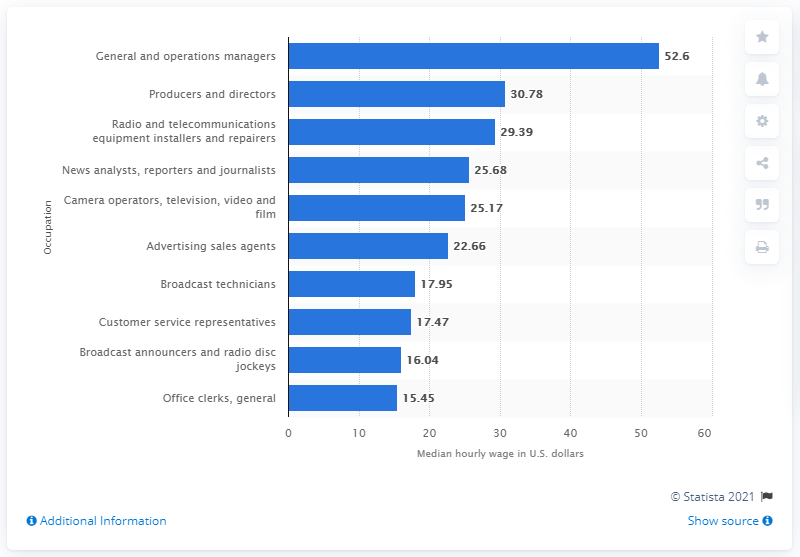Outline some significant characteristics in this image. The median hourly wage of customer service representatives in the U.S. radio and TV broadcasting industry was $17.47. 